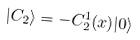Convert formula to latex. <formula><loc_0><loc_0><loc_500><loc_500>| C _ { 2 } \rangle = - C _ { 2 } ^ { 1 } ( x ) | 0 \rangle</formula> 